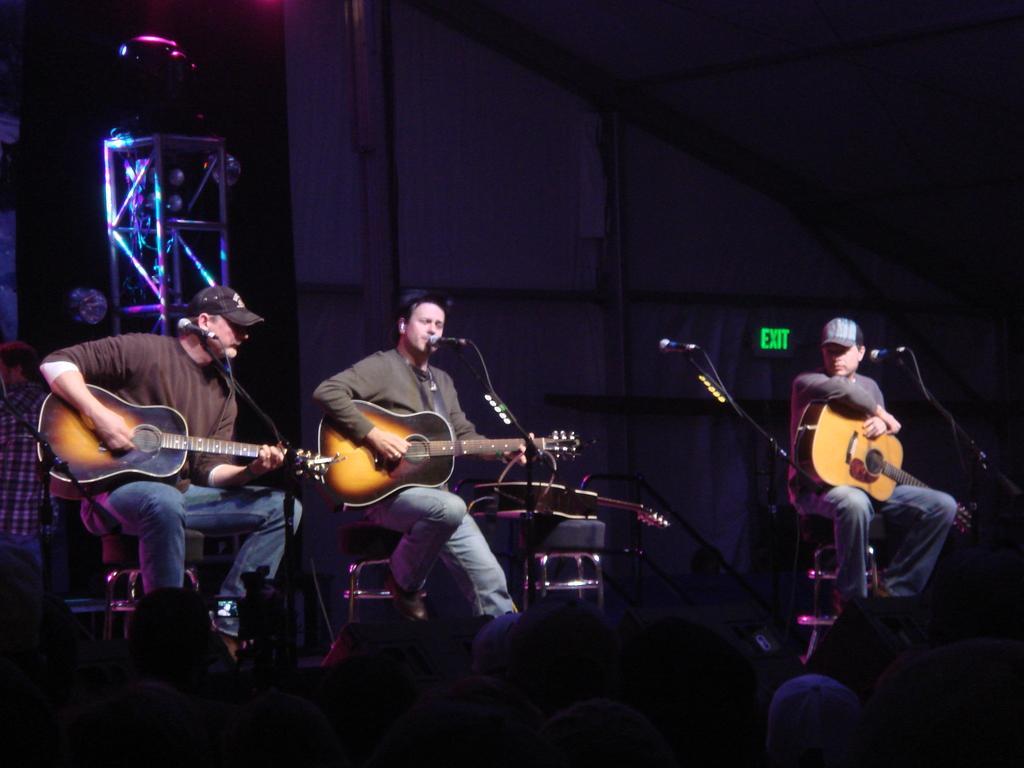In one or two sentences, can you explain what this image depicts? There are three person sitting holding guitar. In front of them there are mics. On the left end a person is wearing a cap and playing guitar. Middle person is playing guitar and singing. In the background there is a stand. 